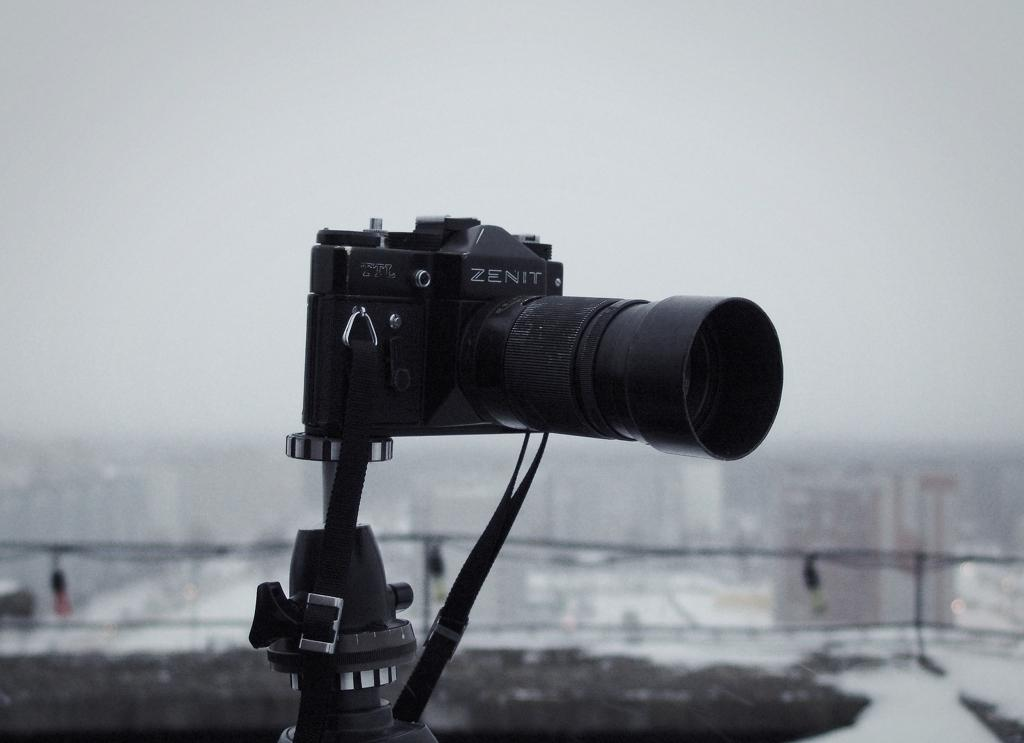What is the main object in the image? There is a camera in the image. How is the camera positioned in the image? The camera is attached to a stand. What can be observed about the background of the image? The background of the image is blurred. How many bombs can be seen in the image? There are no bombs present in the image. What type of lizards are crawling on the floor in the image? There is no floor visible in the image, and no lizards are present. 